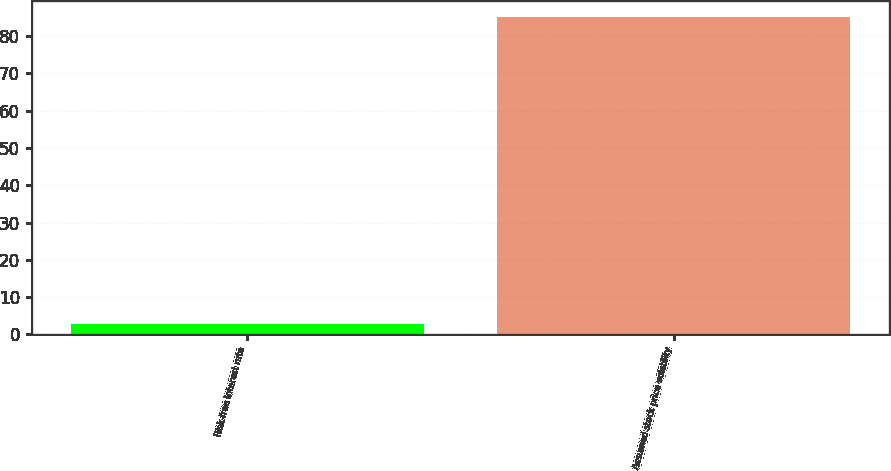<chart> <loc_0><loc_0><loc_500><loc_500><bar_chart><fcel>Risk-free interest rate<fcel>Assumed stock price volatility<nl><fcel>2.92<fcel>85<nl></chart> 